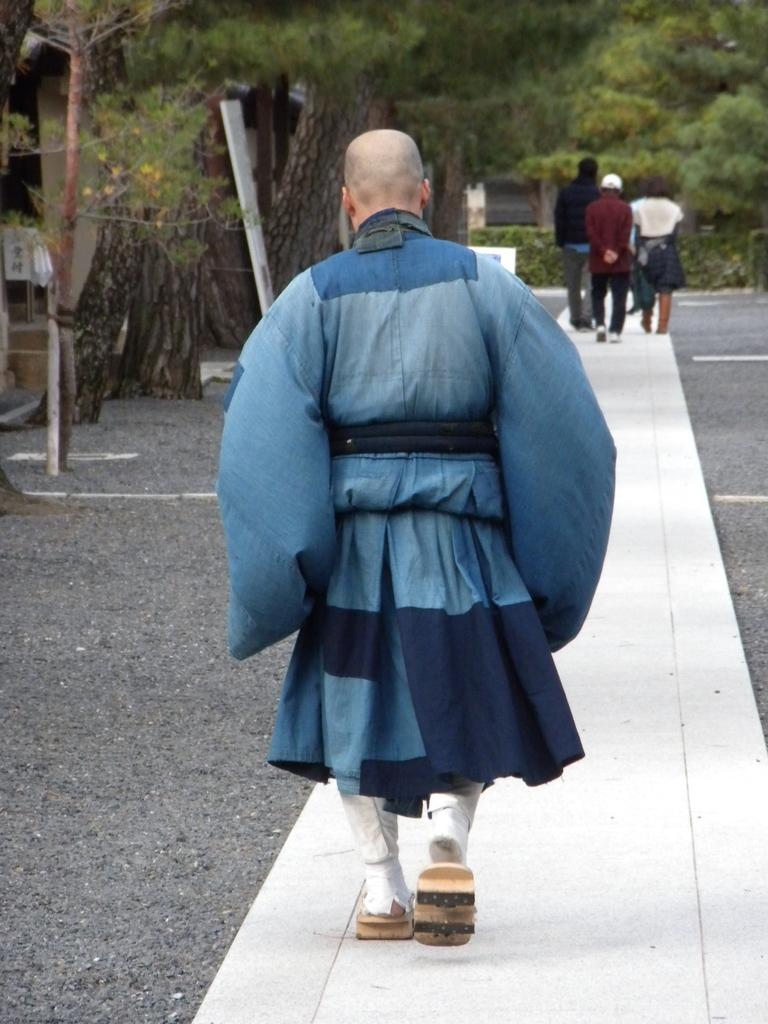What are the people in the image doing? The people in the image are walking on the road. What can be seen in the background of the image? There are trees visible in the background of the image. Can you see a giraffe walking alongside the people in the image? No, there is no giraffe present in the image. Are there any giants visible in the image? No, there are no giants present in the image. 